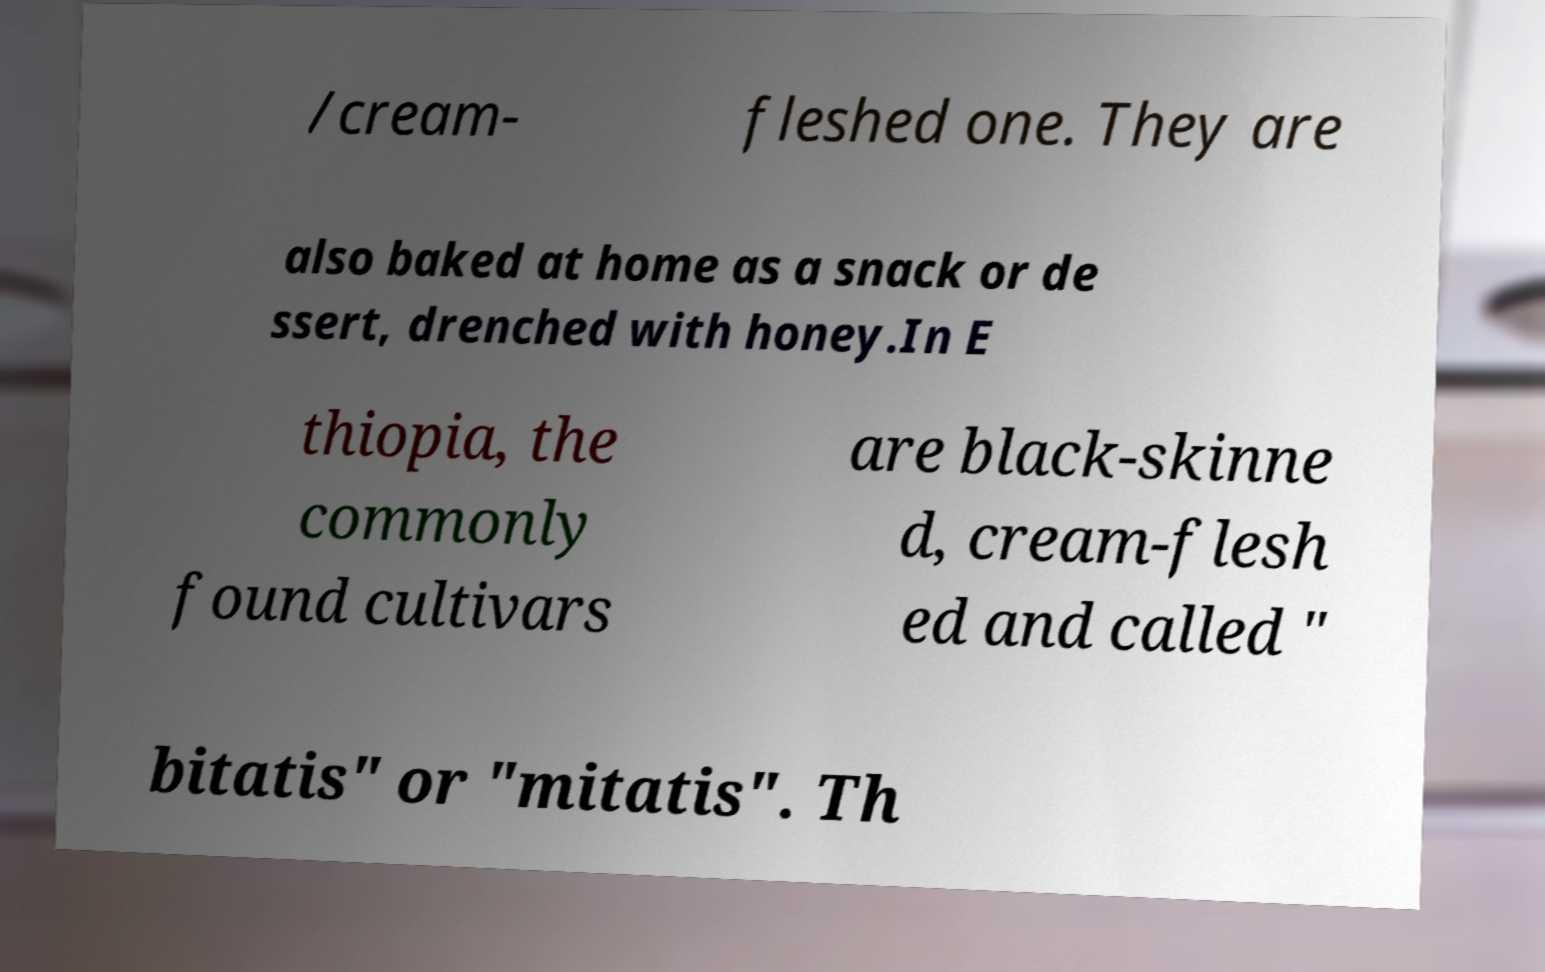I need the written content from this picture converted into text. Can you do that? /cream- fleshed one. They are also baked at home as a snack or de ssert, drenched with honey.In E thiopia, the commonly found cultivars are black-skinne d, cream-flesh ed and called " bitatis" or "mitatis". Th 